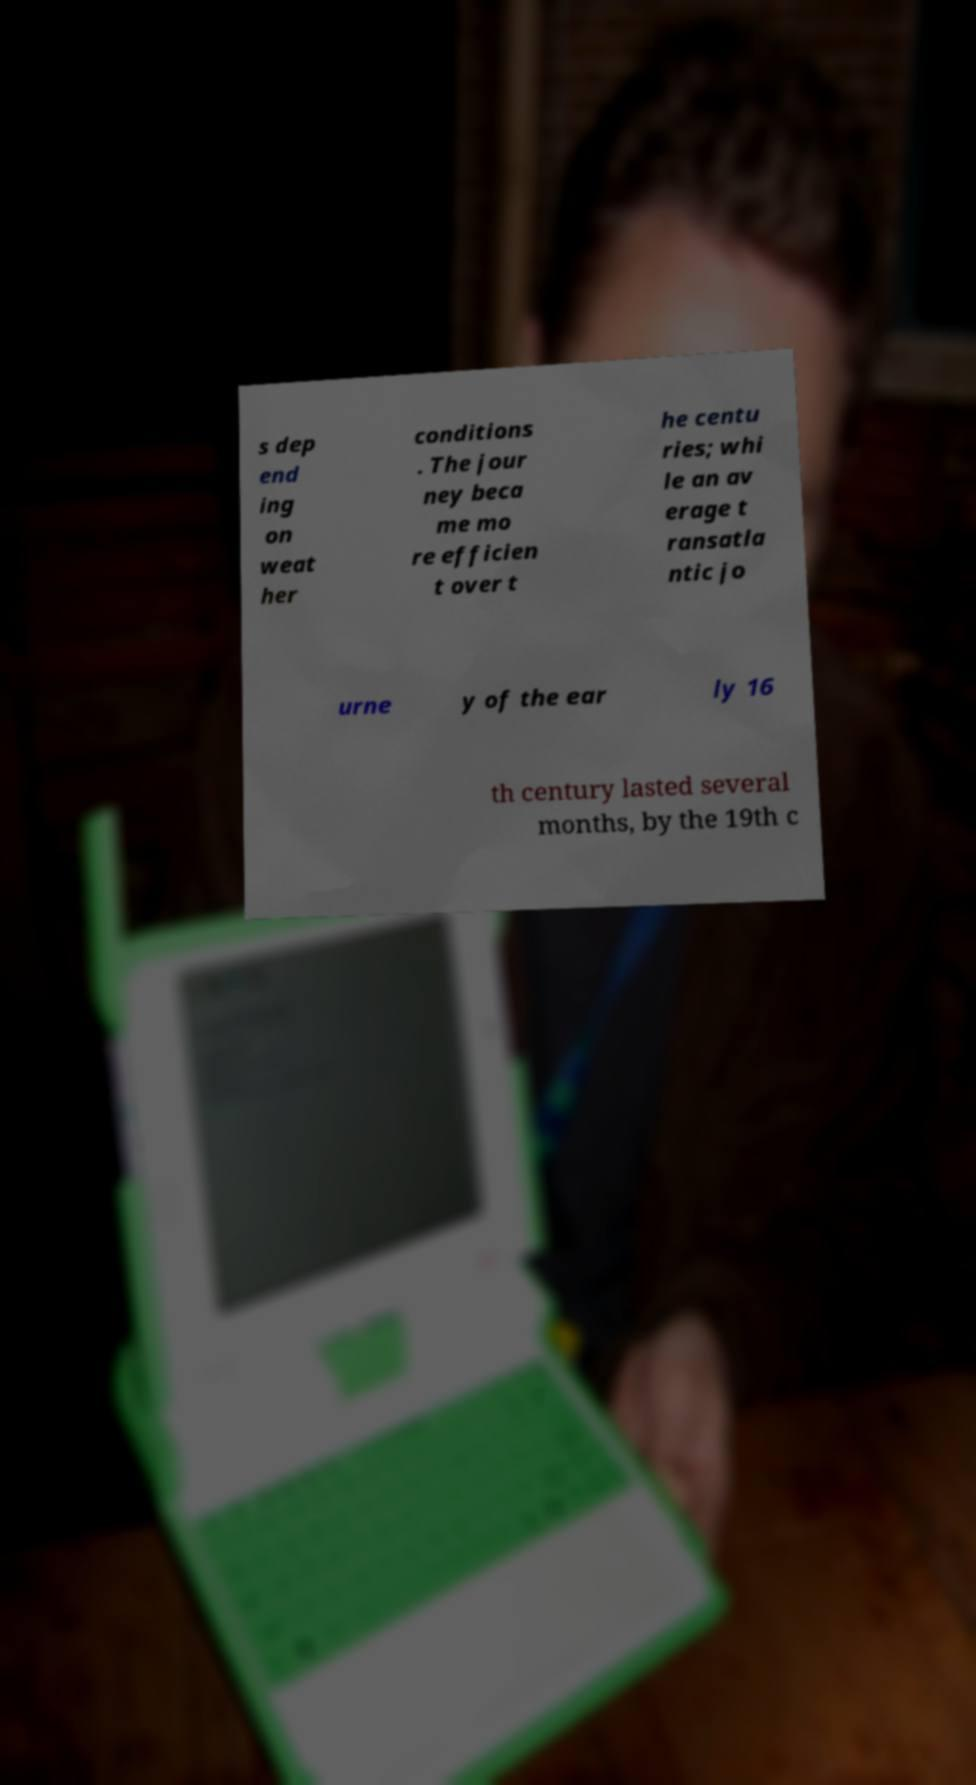What messages or text are displayed in this image? I need them in a readable, typed format. s dep end ing on weat her conditions . The jour ney beca me mo re efficien t over t he centu ries; whi le an av erage t ransatla ntic jo urne y of the ear ly 16 th century lasted several months, by the 19th c 